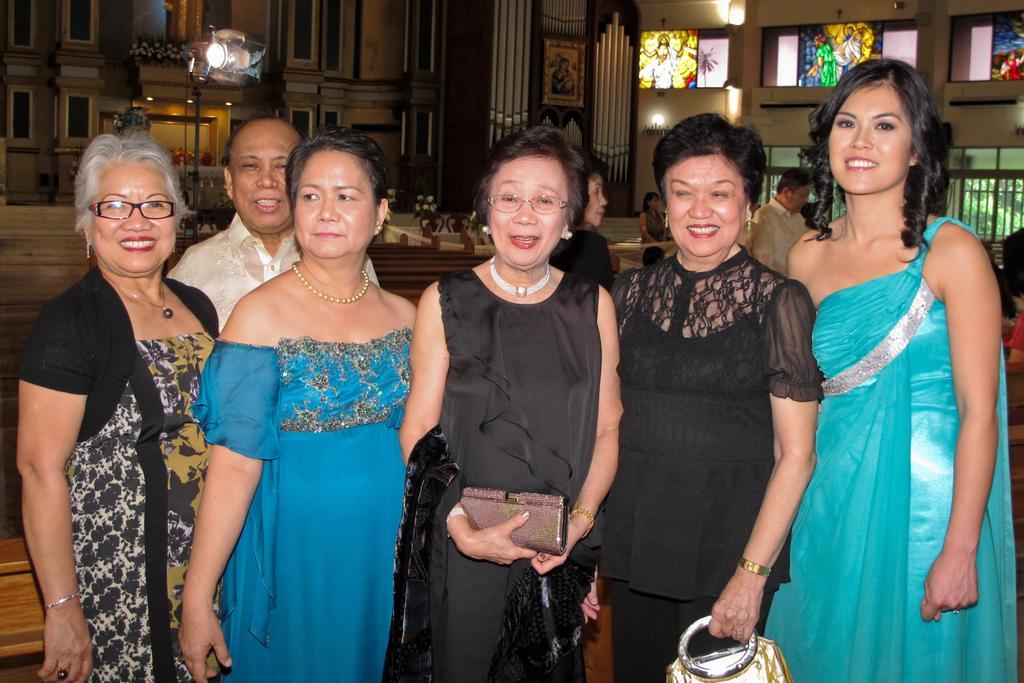Can you describe this image briefly? In this image we can see group of persons standing on the ground. One woman is holding a bag with her hands. One woman is wearing spectacles. In the background, we can see some lights, pillars, photo frames on the wall, a group of windows, chairs and stained glass. 